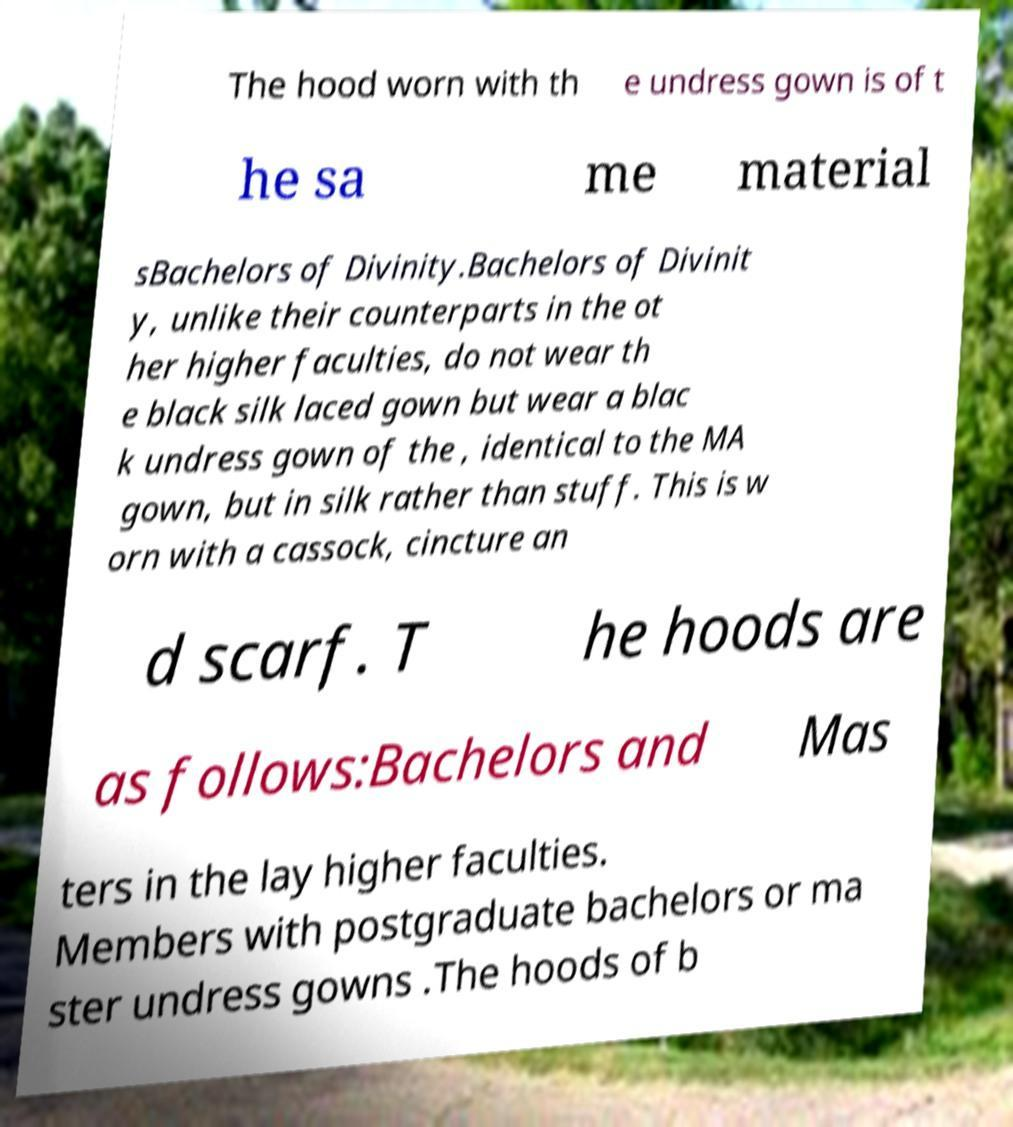Could you assist in decoding the text presented in this image and type it out clearly? The hood worn with th e undress gown is of t he sa me material sBachelors of Divinity.Bachelors of Divinit y, unlike their counterparts in the ot her higher faculties, do not wear th e black silk laced gown but wear a blac k undress gown of the , identical to the MA gown, but in silk rather than stuff. This is w orn with a cassock, cincture an d scarf. T he hoods are as follows:Bachelors and Mas ters in the lay higher faculties. Members with postgraduate bachelors or ma ster undress gowns .The hoods of b 